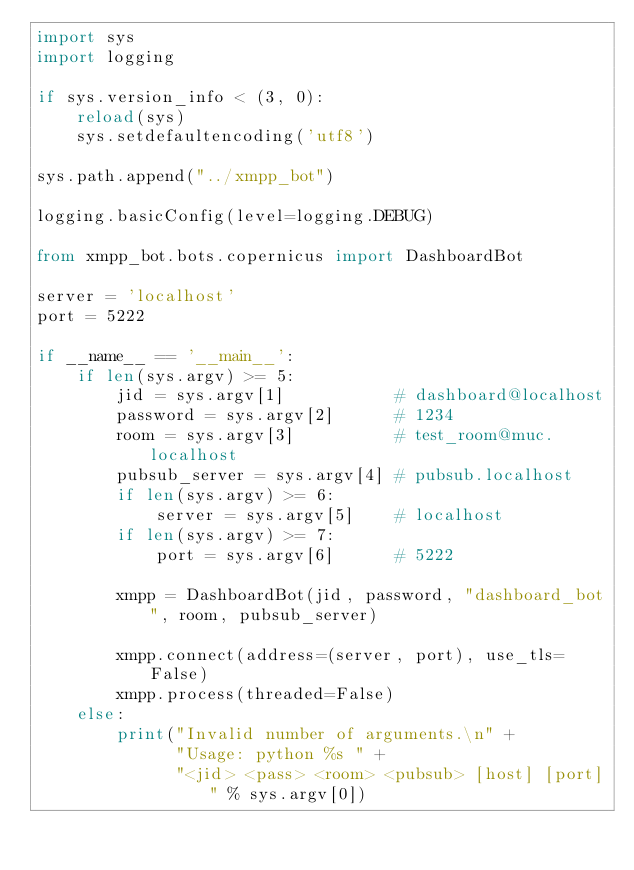Convert code to text. <code><loc_0><loc_0><loc_500><loc_500><_Python_>import sys
import logging

if sys.version_info < (3, 0):
    reload(sys)
    sys.setdefaultencoding('utf8')

sys.path.append("../xmpp_bot")

logging.basicConfig(level=logging.DEBUG)

from xmpp_bot.bots.copernicus import DashboardBot

server = 'localhost'
port = 5222

if __name__ == '__main__':
    if len(sys.argv) >= 5:
        jid = sys.argv[1]           # dashboard@localhost
        password = sys.argv[2]      # 1234
        room = sys.argv[3]          # test_room@muc.localhost
        pubsub_server = sys.argv[4] # pubsub.localhost
        if len(sys.argv) >= 6:
            server = sys.argv[5]    # localhost
        if len(sys.argv) >= 7:
            port = sys.argv[6]      # 5222

        xmpp = DashboardBot(jid, password, "dashboard_bot", room, pubsub_server)

        xmpp.connect(address=(server, port), use_tls=False)
        xmpp.process(threaded=False)
    else:
        print("Invalid number of arguments.\n" +
              "Usage: python %s " +
              "<jid> <pass> <room> <pubsub> [host] [port]" % sys.argv[0])
</code> 